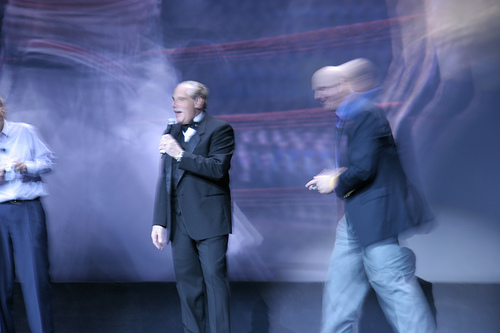<image>
Can you confirm if the man is on the stage? Yes. Looking at the image, I can see the man is positioned on top of the stage, with the stage providing support. Is there a man behind the man? No. The man is not behind the man. From this viewpoint, the man appears to be positioned elsewhere in the scene. 